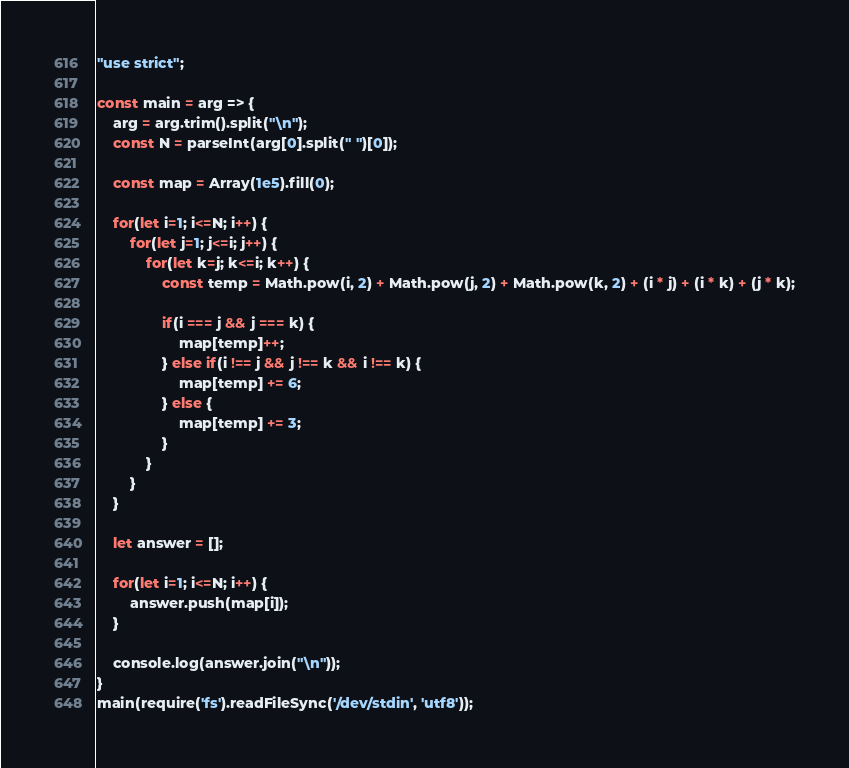<code> <loc_0><loc_0><loc_500><loc_500><_JavaScript_>"use strict";
    
const main = arg => {
    arg = arg.trim().split("\n");
    const N = parseInt(arg[0].split(" ")[0]);
    
    const map = Array(1e5).fill(0);
    
    for(let i=1; i<=N; i++) {
        for(let j=1; j<=i; j++) {
            for(let k=j; k<=i; k++) {
                const temp = Math.pow(i, 2) + Math.pow(j, 2) + Math.pow(k, 2) + (i * j) + (i * k) + (j * k);
                
                if(i === j && j === k) {
                    map[temp]++;
                } else if(i !== j && j !== k && i !== k) {
                    map[temp] += 6;
                } else {
                    map[temp] += 3;
                }
            }            
        }
    }
    
    let answer = [];
    
    for(let i=1; i<=N; i++) {
        answer.push(map[i]);
    }
    
    console.log(answer.join("\n"));
}
main(require('fs').readFileSync('/dev/stdin', 'utf8'));
</code> 